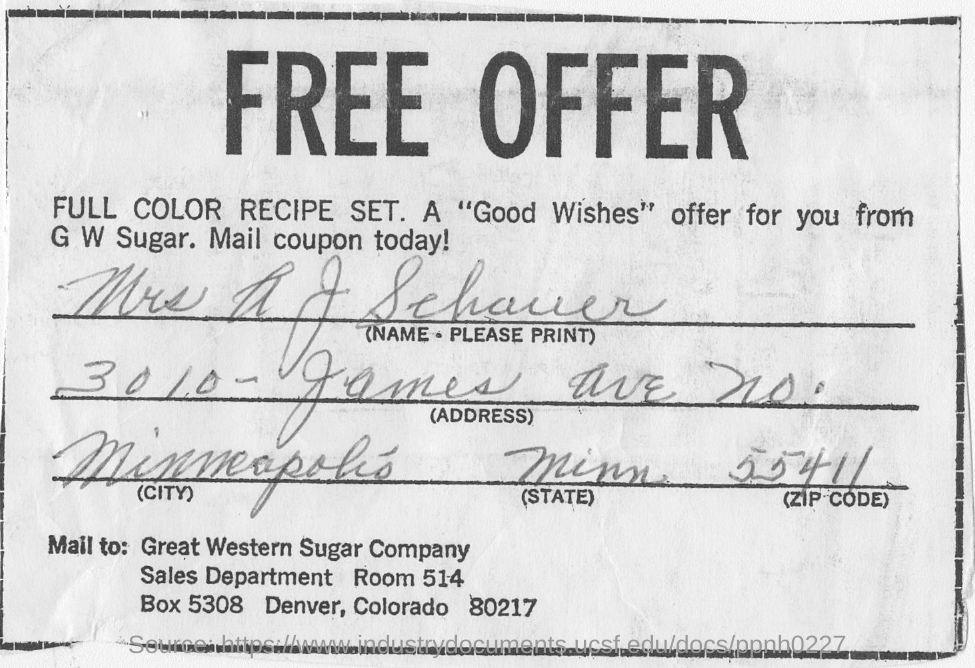Specify some key components in this picture. The title of the document is [insert title]. It is a free offer. 